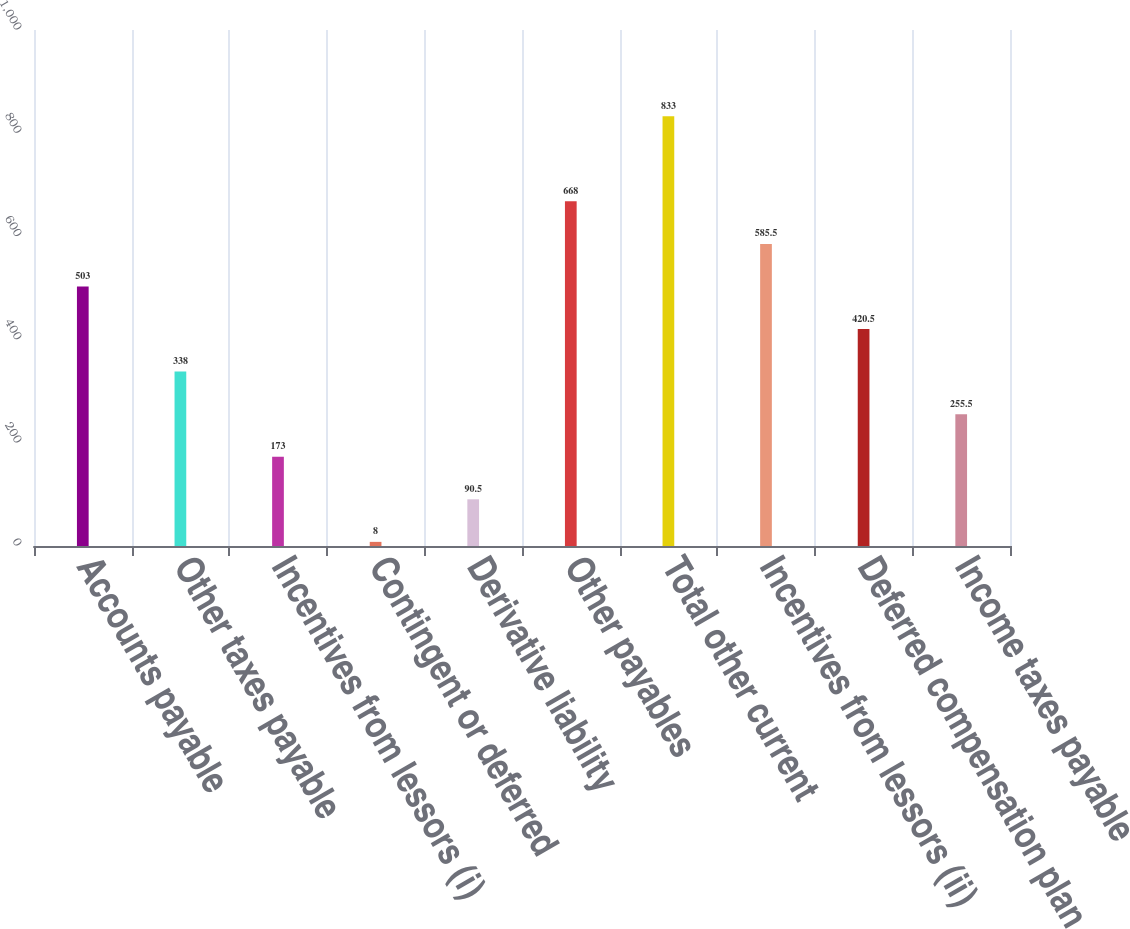<chart> <loc_0><loc_0><loc_500><loc_500><bar_chart><fcel>Accounts payable<fcel>Other taxes payable<fcel>Incentives from lessors (i)<fcel>Contingent or deferred<fcel>Derivative liability<fcel>Other payables<fcel>Total other current<fcel>Incentives from lessors (ii)<fcel>Deferred compensation plan<fcel>Income taxes payable<nl><fcel>503<fcel>338<fcel>173<fcel>8<fcel>90.5<fcel>668<fcel>833<fcel>585.5<fcel>420.5<fcel>255.5<nl></chart> 